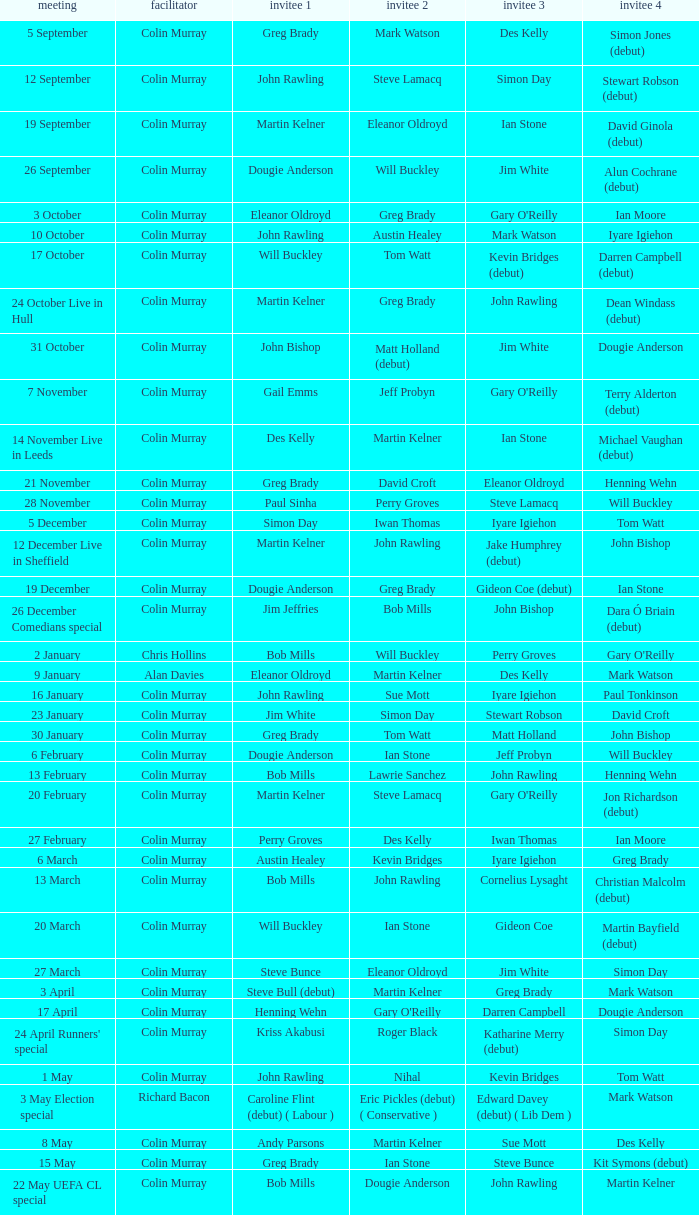How many people are guest 1 on episodes where guest 4 is Des Kelly? 1.0. 